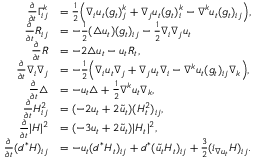Convert formula to latex. <formula><loc_0><loc_0><loc_500><loc_500>\begin{array} { r l } { \frac { \partial } { \partial t } \Gamma _ { i j } ^ { k } } & { = \frac { 1 } { 2 } \left ( \nabla _ { i } u _ { t } ( g _ { t } ) _ { j } ^ { k } + \nabla _ { j } u _ { t } ( g _ { t } ) _ { i } ^ { k } - \nabla ^ { k } u _ { t } ( g _ { t } ) _ { i j } \right ) , } \\ { \frac { \partial } { \partial t } R _ { i j } } & { = - \frac { 1 } { 2 } ( \triangle u _ { t } ) ( g _ { t } ) _ { i j } - \frac { 1 } { 2 } \nabla _ { i } \nabla _ { j } u _ { t } } \\ { \frac { \partial } { \partial t } R } & { = - 2 \triangle u _ { t } - u _ { t } R _ { t } , } \\ { \frac { \partial } { \partial t } \nabla _ { i } \nabla _ { j } } & { = - \frac { 1 } { 2 } \left ( \nabla _ { i } u _ { t } \nabla _ { j } + \nabla _ { j } u _ { t } \nabla _ { i } - \nabla ^ { k } u _ { t } ( g _ { t } ) _ { i j } \nabla _ { k } \right ) , } \\ { \frac { \partial } { \partial t } \triangle } & { = - u _ { t } \triangle + \frac { 1 } { 2 } \nabla ^ { k } u _ { t } \nabla _ { k } , } \\ { \frac { \partial } { \partial t } H _ { i j } ^ { 2 } } & { = ( - 2 u _ { t } + 2 \tilde { u } _ { t } ) ( H _ { t } ^ { 2 } ) _ { i j } , } \\ { \frac { \partial } { \partial t } | H | ^ { 2 } } & { = ( - 3 u _ { t } + 2 \tilde { u } _ { t } ) | H _ { t } | ^ { 2 } , } \\ { \frac { \partial } { \partial t } ( d ^ { * } H ) _ { i j } } & { = - u _ { t } ( d ^ { * } H _ { t } ) _ { i j } + d ^ { * } ( \tilde { u _ { t } } H _ { t } ) _ { i j } + \frac { 3 } { 2 } ( i _ { \nabla u _ { t } } H ) _ { i j } . } \end{array}</formula> 